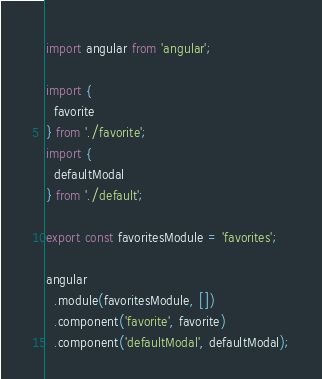<code> <loc_0><loc_0><loc_500><loc_500><_JavaScript_>import angular from 'angular';

import {
  favorite
} from './favorite';
import {
  defaultModal
} from './default';

export const favoritesModule = 'favorites';

angular
  .module(favoritesModule, [])
  .component('favorite', favorite)
  .component('defaultModal', defaultModal);
</code> 